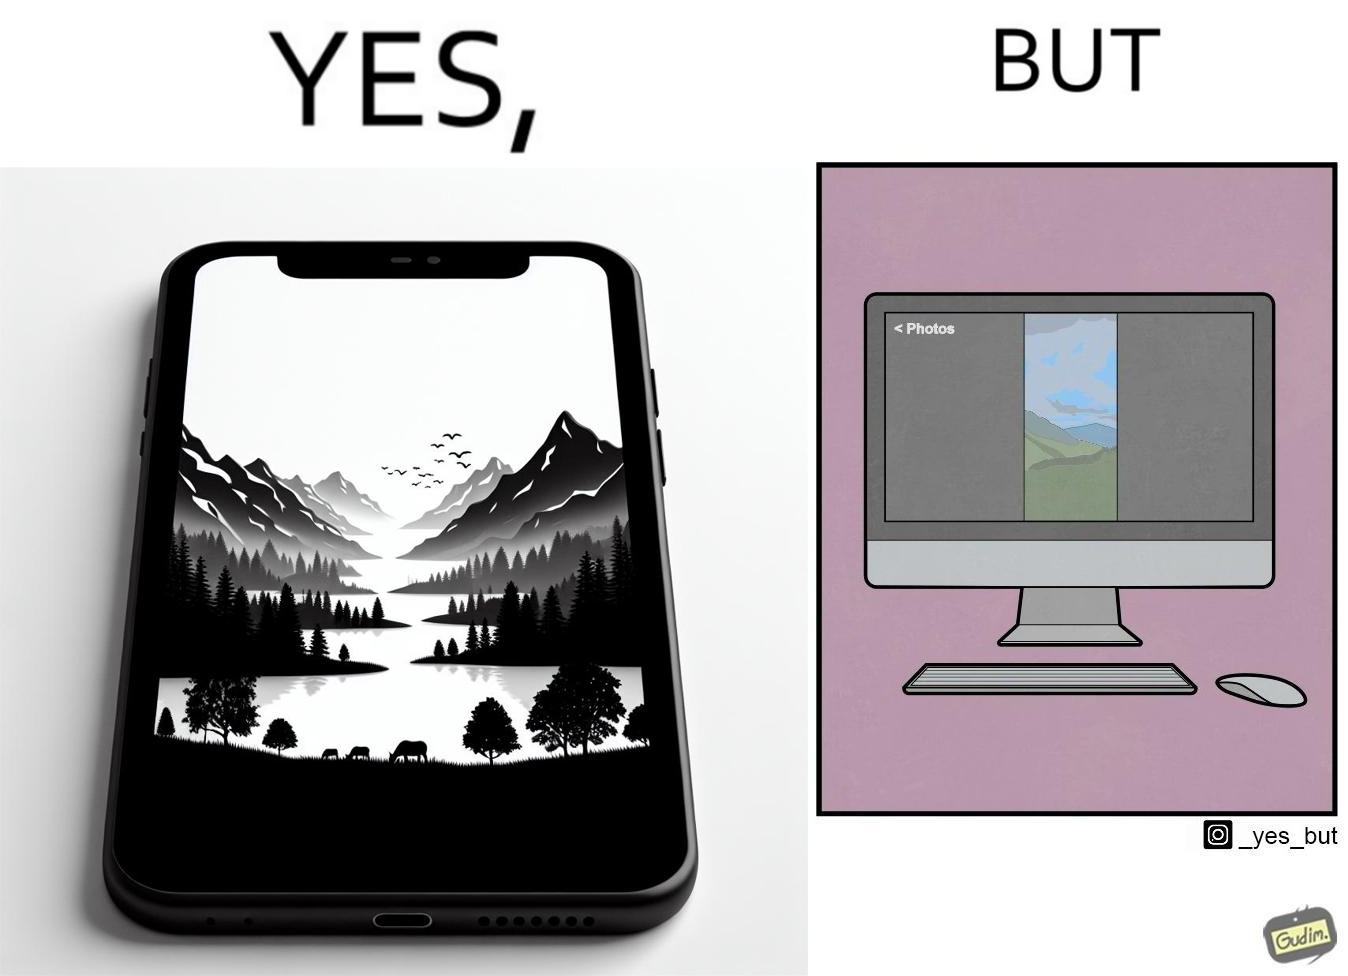Is this a satirical image? Yes, this image is satirical. 